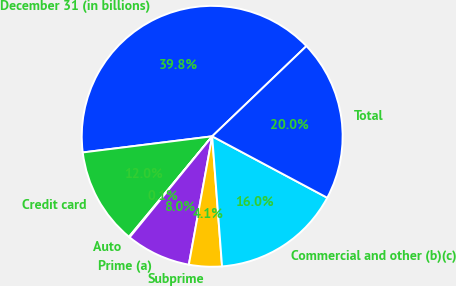<chart> <loc_0><loc_0><loc_500><loc_500><pie_chart><fcel>December 31 (in billions)<fcel>Credit card<fcel>Auto<fcel>Prime (a)<fcel>Subprime<fcel>Commercial and other (b)(c)<fcel>Total<nl><fcel>39.82%<fcel>12.02%<fcel>0.1%<fcel>8.04%<fcel>4.07%<fcel>15.99%<fcel>19.96%<nl></chart> 